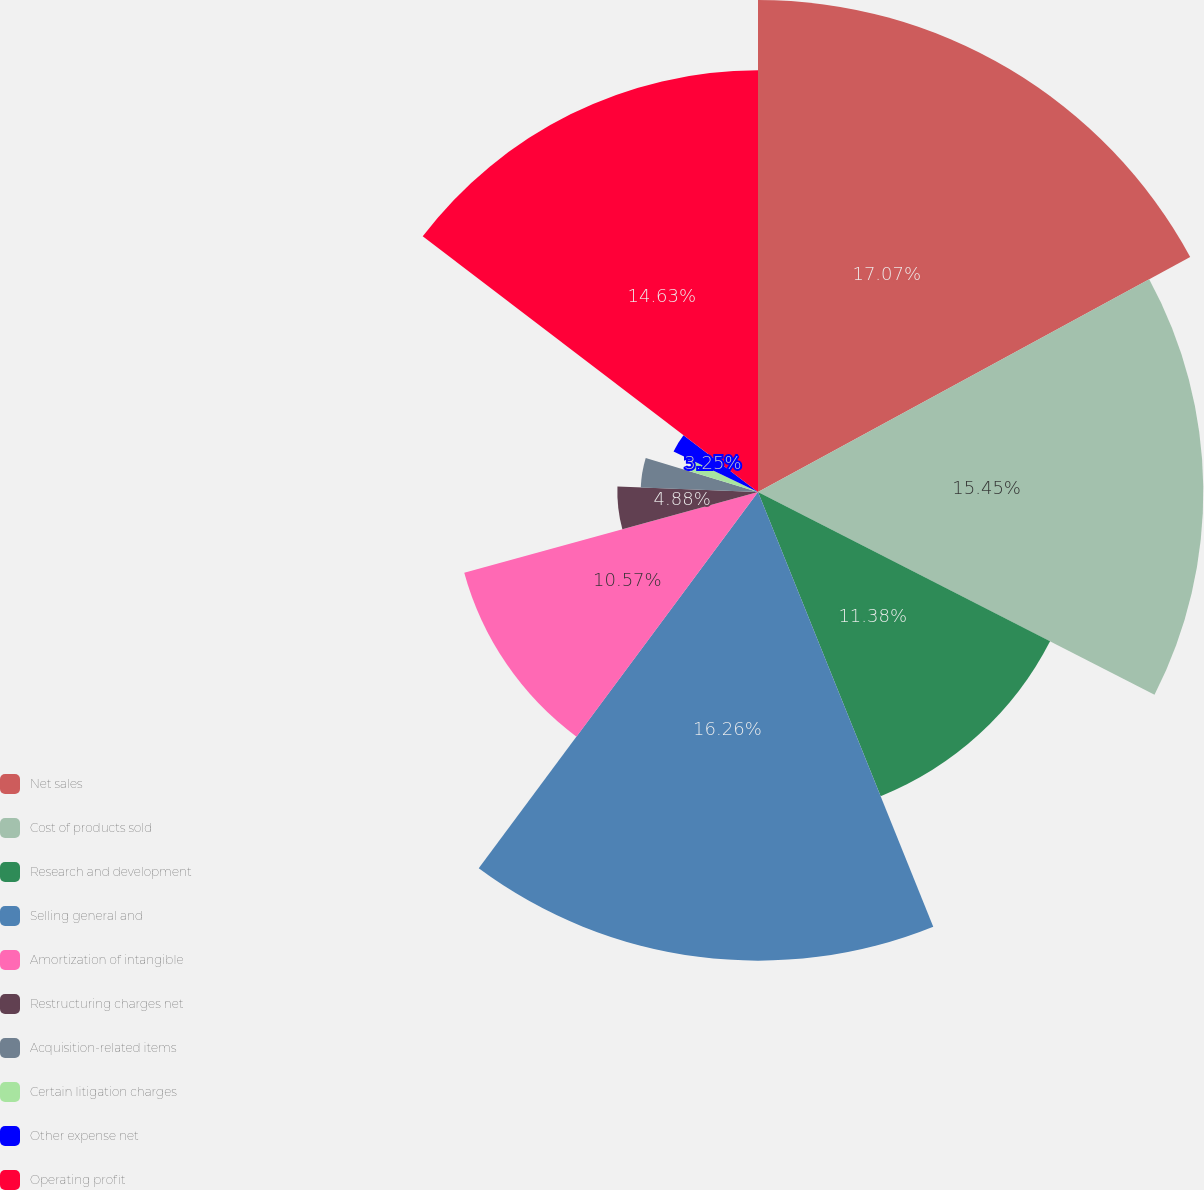Convert chart. <chart><loc_0><loc_0><loc_500><loc_500><pie_chart><fcel>Net sales<fcel>Cost of products sold<fcel>Research and development<fcel>Selling general and<fcel>Amortization of intangible<fcel>Restructuring charges net<fcel>Acquisition-related items<fcel>Certain litigation charges<fcel>Other expense net<fcel>Operating profit<nl><fcel>17.07%<fcel>15.45%<fcel>11.38%<fcel>16.26%<fcel>10.57%<fcel>4.88%<fcel>4.07%<fcel>2.44%<fcel>3.25%<fcel>14.63%<nl></chart> 